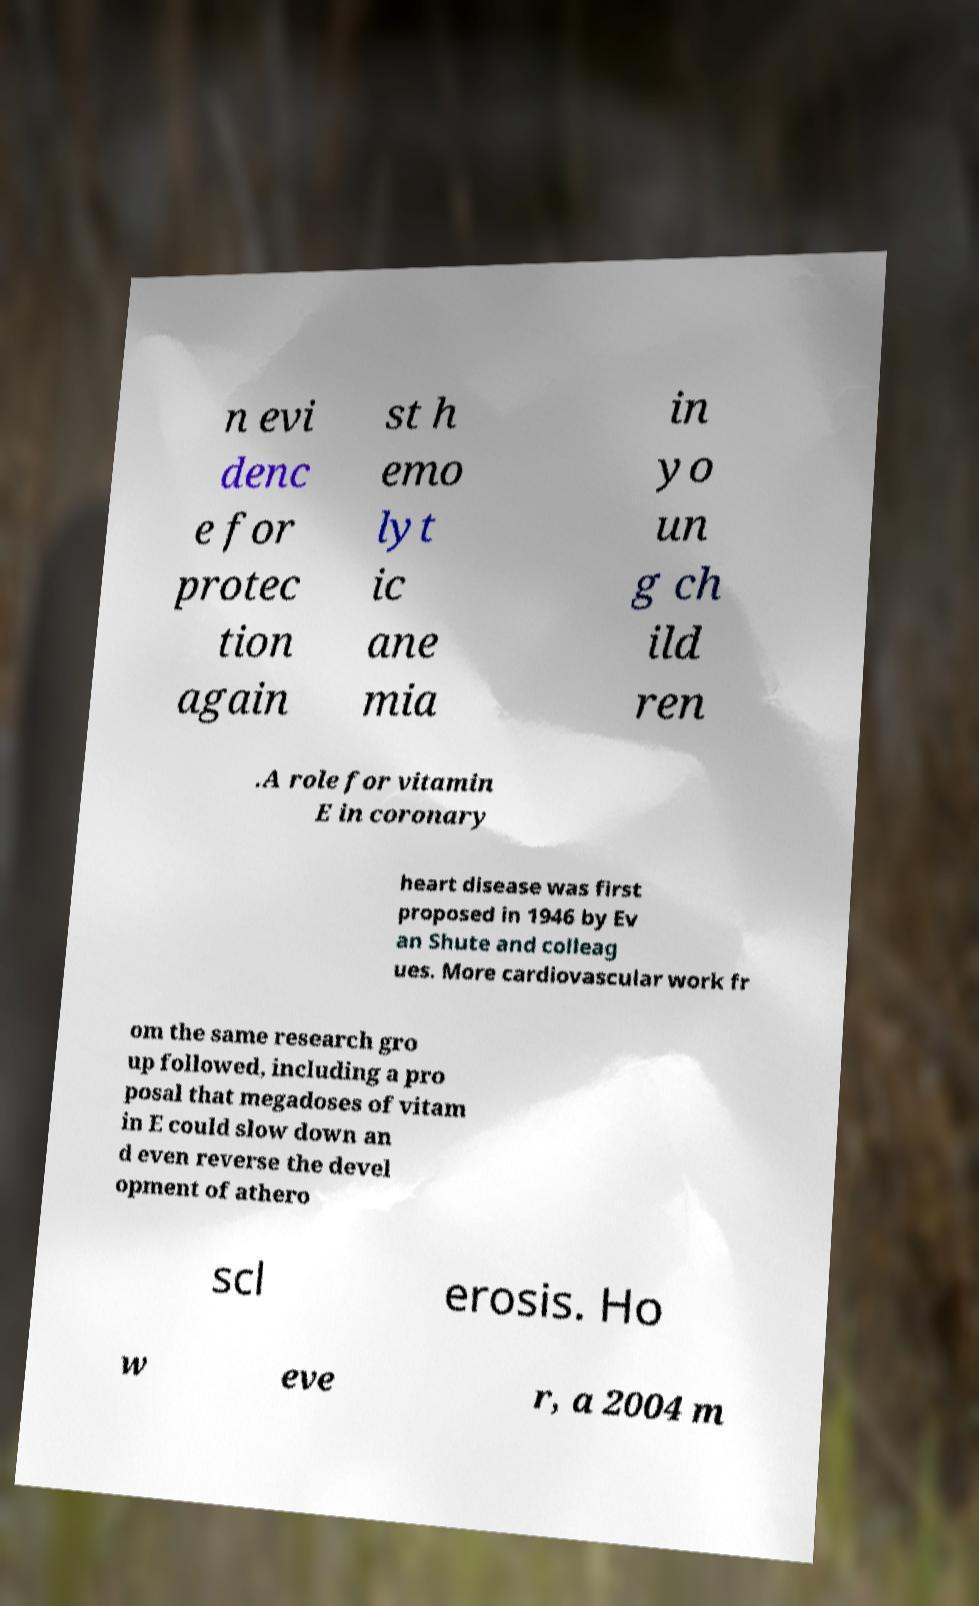Please read and relay the text visible in this image. What does it say? n evi denc e for protec tion again st h emo lyt ic ane mia in yo un g ch ild ren .A role for vitamin E in coronary heart disease was first proposed in 1946 by Ev an Shute and colleag ues. More cardiovascular work fr om the same research gro up followed, including a pro posal that megadoses of vitam in E could slow down an d even reverse the devel opment of athero scl erosis. Ho w eve r, a 2004 m 